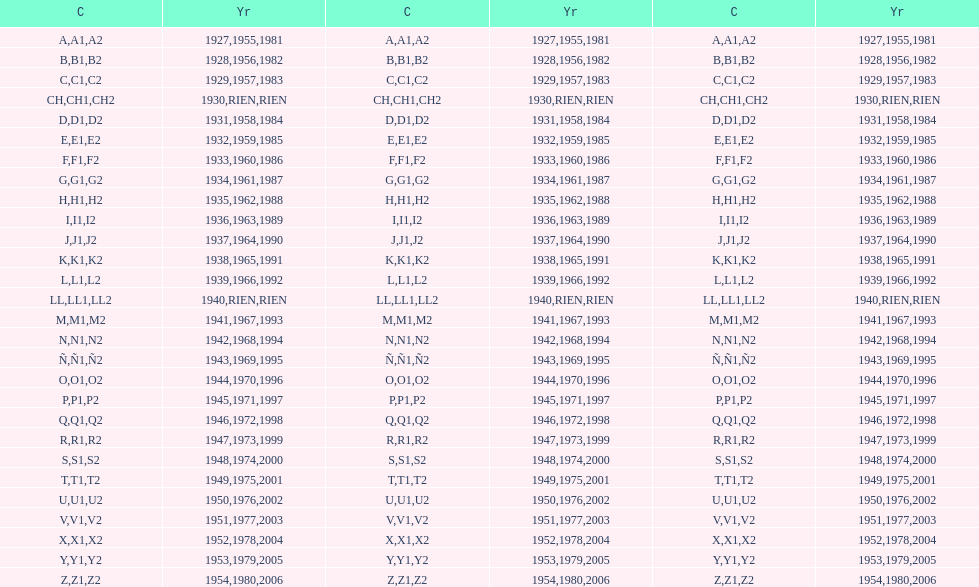Number of codes containing a 2? 28. 